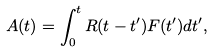Convert formula to latex. <formula><loc_0><loc_0><loc_500><loc_500>A ( t ) = \int _ { 0 } ^ { t } R ( t - t ^ { \prime } ) F ( t ^ { \prime } ) d t ^ { \prime } ,</formula> 